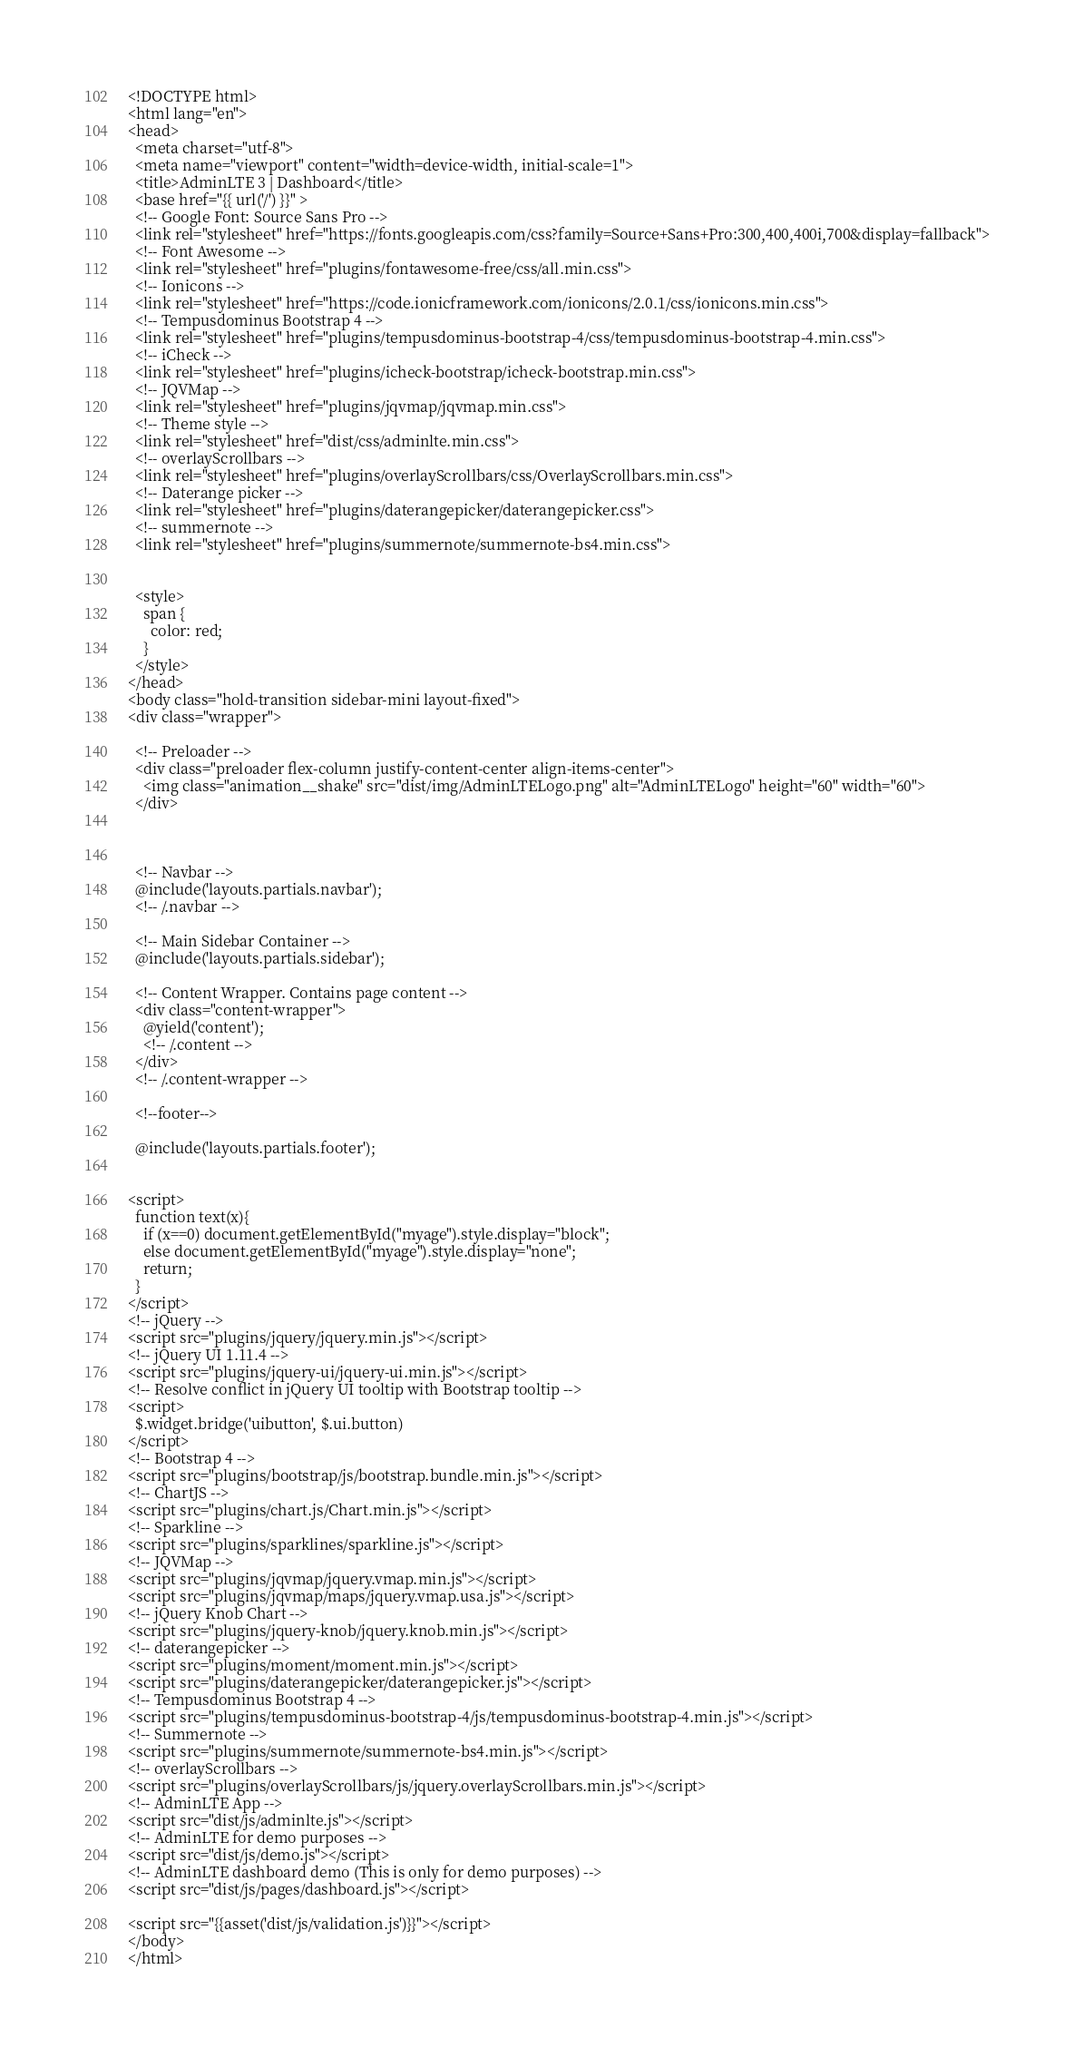Convert code to text. <code><loc_0><loc_0><loc_500><loc_500><_PHP_><!DOCTYPE html>
<html lang="en">
<head>
  <meta charset="utf-8">
  <meta name="viewport" content="width=device-width, initial-scale=1">
  <title>AdminLTE 3 | Dashboard</title>
  <base href="{{ url('/') }}" >
  <!-- Google Font: Source Sans Pro -->
  <link rel="stylesheet" href="https://fonts.googleapis.com/css?family=Source+Sans+Pro:300,400,400i,700&display=fallback">
  <!-- Font Awesome -->
  <link rel="stylesheet" href="plugins/fontawesome-free/css/all.min.css">
  <!-- Ionicons -->
  <link rel="stylesheet" href="https://code.ionicframework.com/ionicons/2.0.1/css/ionicons.min.css">
  <!-- Tempusdominus Bootstrap 4 -->
  <link rel="stylesheet" href="plugins/tempusdominus-bootstrap-4/css/tempusdominus-bootstrap-4.min.css">
  <!-- iCheck -->
  <link rel="stylesheet" href="plugins/icheck-bootstrap/icheck-bootstrap.min.css">
  <!-- JQVMap -->
  <link rel="stylesheet" href="plugins/jqvmap/jqvmap.min.css">
  <!-- Theme style -->
  <link rel="stylesheet" href="dist/css/adminlte.min.css">
  <!-- overlayScrollbars -->
  <link rel="stylesheet" href="plugins/overlayScrollbars/css/OverlayScrollbars.min.css">
  <!-- Daterange picker -->
  <link rel="stylesheet" href="plugins/daterangepicker/daterangepicker.css">
  <!-- summernote -->
  <link rel="stylesheet" href="plugins/summernote/summernote-bs4.min.css">


  <style>
    span {
      color: red;
    }
  </style>
</head>
<body class="hold-transition sidebar-mini layout-fixed">
<div class="wrapper">

  <!-- Preloader -->
  <div class="preloader flex-column justify-content-center align-items-center">
    <img class="animation__shake" src="dist/img/AdminLTELogo.png" alt="AdminLTELogo" height="60" width="60">
  </div>



  <!-- Navbar -->
  @include('layouts.partials.navbar');
  <!-- /.navbar -->

  <!-- Main Sidebar Container -->
  @include('layouts.partials.sidebar');

  <!-- Content Wrapper. Contains page content -->
  <div class="content-wrapper">
    @yield('content');
    <!-- /.content -->
  </div>
  <!-- /.content-wrapper -->
  
  <!--footer-->

  @include('layouts.partials.footer');


<script>
  function text(x){
    if (x==0) document.getElementById("myage").style.display="block";
    else document.getElementById("myage").style.display="none";
    return;
  }
</script>
<!-- jQuery -->
<script src="plugins/jquery/jquery.min.js"></script>
<!-- jQuery UI 1.11.4 -->
<script src="plugins/jquery-ui/jquery-ui.min.js"></script>
<!-- Resolve conflict in jQuery UI tooltip with Bootstrap tooltip -->
<script>
  $.widget.bridge('uibutton', $.ui.button)
</script>
<!-- Bootstrap 4 -->
<script src="plugins/bootstrap/js/bootstrap.bundle.min.js"></script>
<!-- ChartJS -->
<script src="plugins/chart.js/Chart.min.js"></script>
<!-- Sparkline -->
<script src="plugins/sparklines/sparkline.js"></script>
<!-- JQVMap -->
<script src="plugins/jqvmap/jquery.vmap.min.js"></script>
<script src="plugins/jqvmap/maps/jquery.vmap.usa.js"></script>
<!-- jQuery Knob Chart -->
<script src="plugins/jquery-knob/jquery.knob.min.js"></script>
<!-- daterangepicker -->
<script src="plugins/moment/moment.min.js"></script>
<script src="plugins/daterangepicker/daterangepicker.js"></script>
<!-- Tempusdominus Bootstrap 4 -->
<script src="plugins/tempusdominus-bootstrap-4/js/tempusdominus-bootstrap-4.min.js"></script>
<!-- Summernote -->
<script src="plugins/summernote/summernote-bs4.min.js"></script>
<!-- overlayScrollbars -->
<script src="plugins/overlayScrollbars/js/jquery.overlayScrollbars.min.js"></script>
<!-- AdminLTE App -->
<script src="dist/js/adminlte.js"></script>
<!-- AdminLTE for demo purposes -->
<script src="dist/js/demo.js"></script>
<!-- AdminLTE dashboard demo (This is only for demo purposes) -->
<script src="dist/js/pages/dashboard.js"></script>

<script src="{{asset('dist/js/validation.js')}}"></script>
</body>
</html>


</code> 